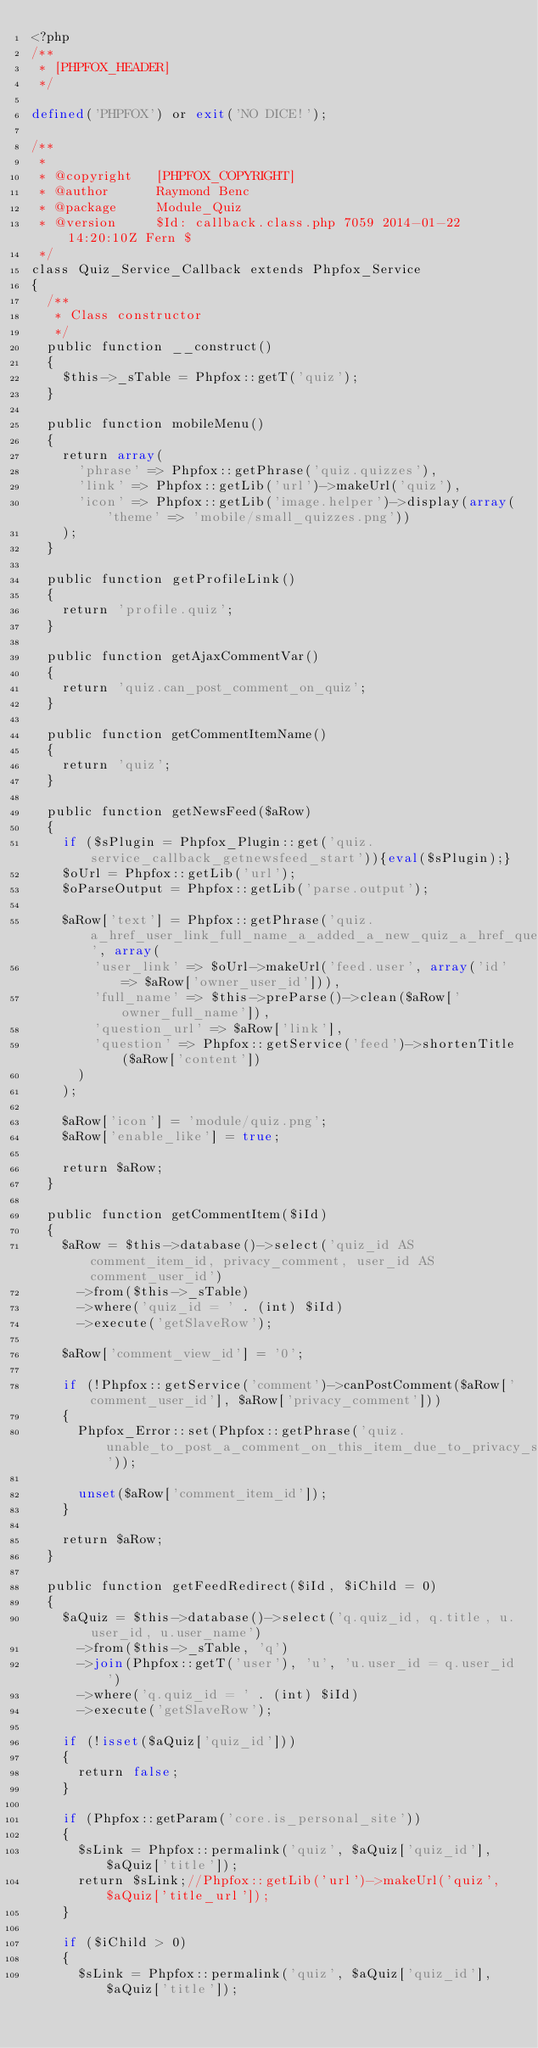<code> <loc_0><loc_0><loc_500><loc_500><_PHP_><?php
/**
 * [PHPFOX_HEADER]
 */

defined('PHPFOX') or exit('NO DICE!');

/**
 * 
 * @copyright		[PHPFOX_COPYRIGHT]
 * @author  		Raymond Benc
 * @package  		Module_Quiz
 * @version 		$Id: callback.class.php 7059 2014-01-22 14:20:10Z Fern $
 */
class Quiz_Service_Callback extends Phpfox_Service 
{
	/**
	 * Class constructor
	 */	
	public function __construct()
	{	
		$this->_sTable = Phpfox::getT('quiz');
	}
	
	public function mobileMenu()
	{
		return array(
			'phrase' => Phpfox::getPhrase('quiz.quizzes'),
			'link' => Phpfox::getLib('url')->makeUrl('quiz'),
			'icon' => Phpfox::getLib('image.helper')->display(array('theme' => 'mobile/small_quizzes.png'))
		);
	}	
	
	public function getProfileLink()
	{
		return 'profile.quiz';
	}

	public function getAjaxCommentVar()
	{
		return 'quiz.can_post_comment_on_quiz';
	}

	public function getCommentItemName()
	{
		return 'quiz';
	}
	
	public function getNewsFeed($aRow)
	{
		if ($sPlugin = Phpfox_Plugin::get('quiz.service_callback_getnewsfeed_start')){eval($sPlugin);}
		$oUrl = Phpfox::getLib('url');
		$oParseOutput = Phpfox::getLib('parse.output');

		$aRow['text'] = Phpfox::getPhrase('quiz.a_href_user_link_full_name_a_added_a_new_quiz_a_href_question_url_question_a', array(
				'user_link' => $oUrl->makeUrl('feed.user', array('id' => $aRow['owner_user_id'])),
				'full_name' => $this->preParse()->clean($aRow['owner_full_name']),
				'question_url' => $aRow['link'],
				'question' => Phpfox::getService('feed')->shortenTitle($aRow['content'])
			)
		);	
		
		$aRow['icon'] = 'module/quiz.png';
		$aRow['enable_like'] = true;

		return $aRow;
	}
	
	public function getCommentItem($iId)
	{
		$aRow = $this->database()->select('quiz_id AS comment_item_id, privacy_comment, user_id AS comment_user_id')
			->from($this->_sTable)
			->where('quiz_id = ' . (int) $iId)
			->execute('getSlaveRow');
			
		$aRow['comment_view_id'] = '0';
		
		if (!Phpfox::getService('comment')->canPostComment($aRow['comment_user_id'], $aRow['privacy_comment']))
		{
			Phpfox_Error::set(Phpfox::getPhrase('quiz.unable_to_post_a_comment_on_this_item_due_to_privacy_settings'));
			
			unset($aRow['comment_item_id']);
		}
		
		return $aRow;
	}

	public function getFeedRedirect($iId, $iChild = 0)
	{
		$aQuiz = $this->database()->select('q.quiz_id, q.title, u.user_id, u.user_name')
			->from($this->_sTable, 'q')
			->join(Phpfox::getT('user'), 'u', 'u.user_id = q.user_id')
			->where('q.quiz_id = ' . (int) $iId)
			->execute('getSlaveRow');

		if (!isset($aQuiz['quiz_id']))
		{
			return false;
		}

		if (Phpfox::getParam('core.is_personal_site'))
		{
			$sLink = Phpfox::permalink('quiz', $aQuiz['quiz_id'], $aQuiz['title']);
			return $sLink;//Phpfox::getLib('url')->makeUrl('quiz', $aQuiz['title_url']);
		}

		if ($iChild > 0)
		{
			$sLink = Phpfox::permalink('quiz', $aQuiz['quiz_id'], $aQuiz['title']);</code> 